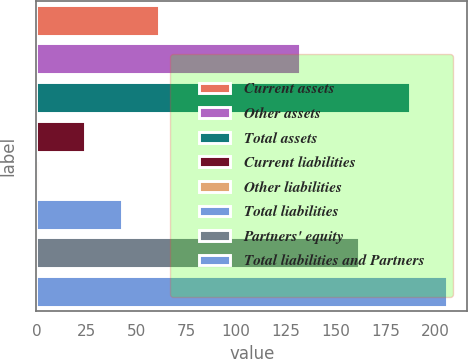<chart> <loc_0><loc_0><loc_500><loc_500><bar_chart><fcel>Current assets<fcel>Other assets<fcel>Total assets<fcel>Current liabilities<fcel>Other liabilities<fcel>Total liabilities<fcel>Partners' equity<fcel>Total liabilities and Partners<nl><fcel>61.52<fcel>132<fcel>187<fcel>24.4<fcel>1.4<fcel>42.96<fcel>161.5<fcel>205.56<nl></chart> 